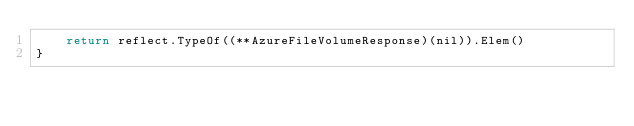Convert code to text. <code><loc_0><loc_0><loc_500><loc_500><_Go_>	return reflect.TypeOf((**AzureFileVolumeResponse)(nil)).Elem()
}
</code> 